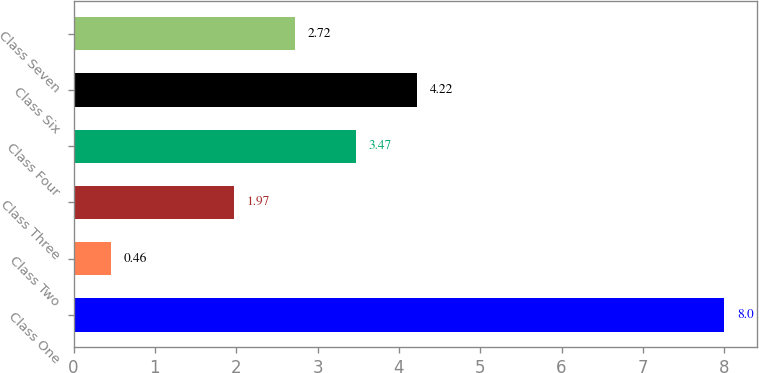<chart> <loc_0><loc_0><loc_500><loc_500><bar_chart><fcel>Class One<fcel>Class Two<fcel>Class Three<fcel>Class Four<fcel>Class Six<fcel>Class Seven<nl><fcel>8<fcel>0.46<fcel>1.97<fcel>3.47<fcel>4.22<fcel>2.72<nl></chart> 